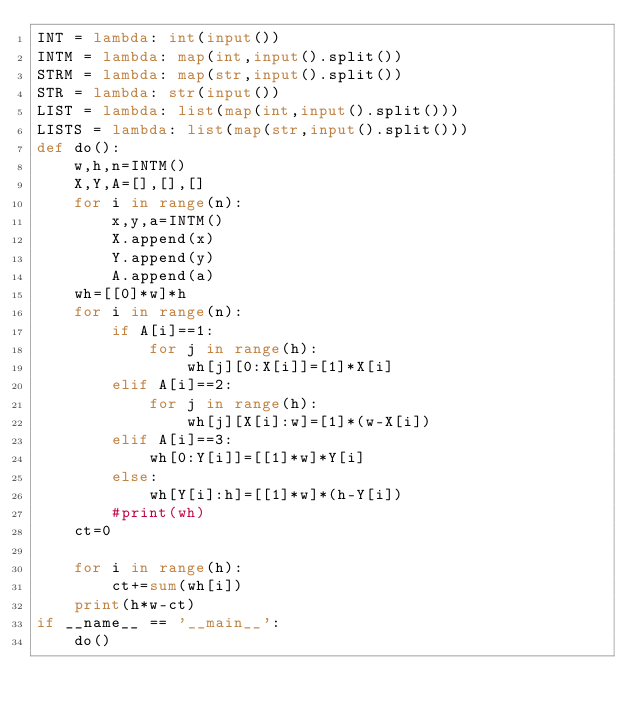Convert code to text. <code><loc_0><loc_0><loc_500><loc_500><_Python_>INT = lambda: int(input())
INTM = lambda: map(int,input().split())
STRM = lambda: map(str,input().split())
STR = lambda: str(input())
LIST = lambda: list(map(int,input().split()))
LISTS = lambda: list(map(str,input().split()))
def do():
    w,h,n=INTM()
    X,Y,A=[],[],[]
    for i in range(n):
        x,y,a=INTM()
        X.append(x)
        Y.append(y)
        A.append(a)
    wh=[[0]*w]*h
    for i in range(n):
        if A[i]==1:
            for j in range(h):
                wh[j][0:X[i]]=[1]*X[i]
        elif A[i]==2:
            for j in range(h):
                wh[j][X[i]:w]=[1]*(w-X[i])
        elif A[i]==3:
            wh[0:Y[i]]=[[1]*w]*Y[i]
        else:
            wh[Y[i]:h]=[[1]*w]*(h-Y[i])
        #print(wh)
    ct=0
    
    for i in range(h):
        ct+=sum(wh[i])
    print(h*w-ct)
if __name__ == '__main__':
    do()</code> 